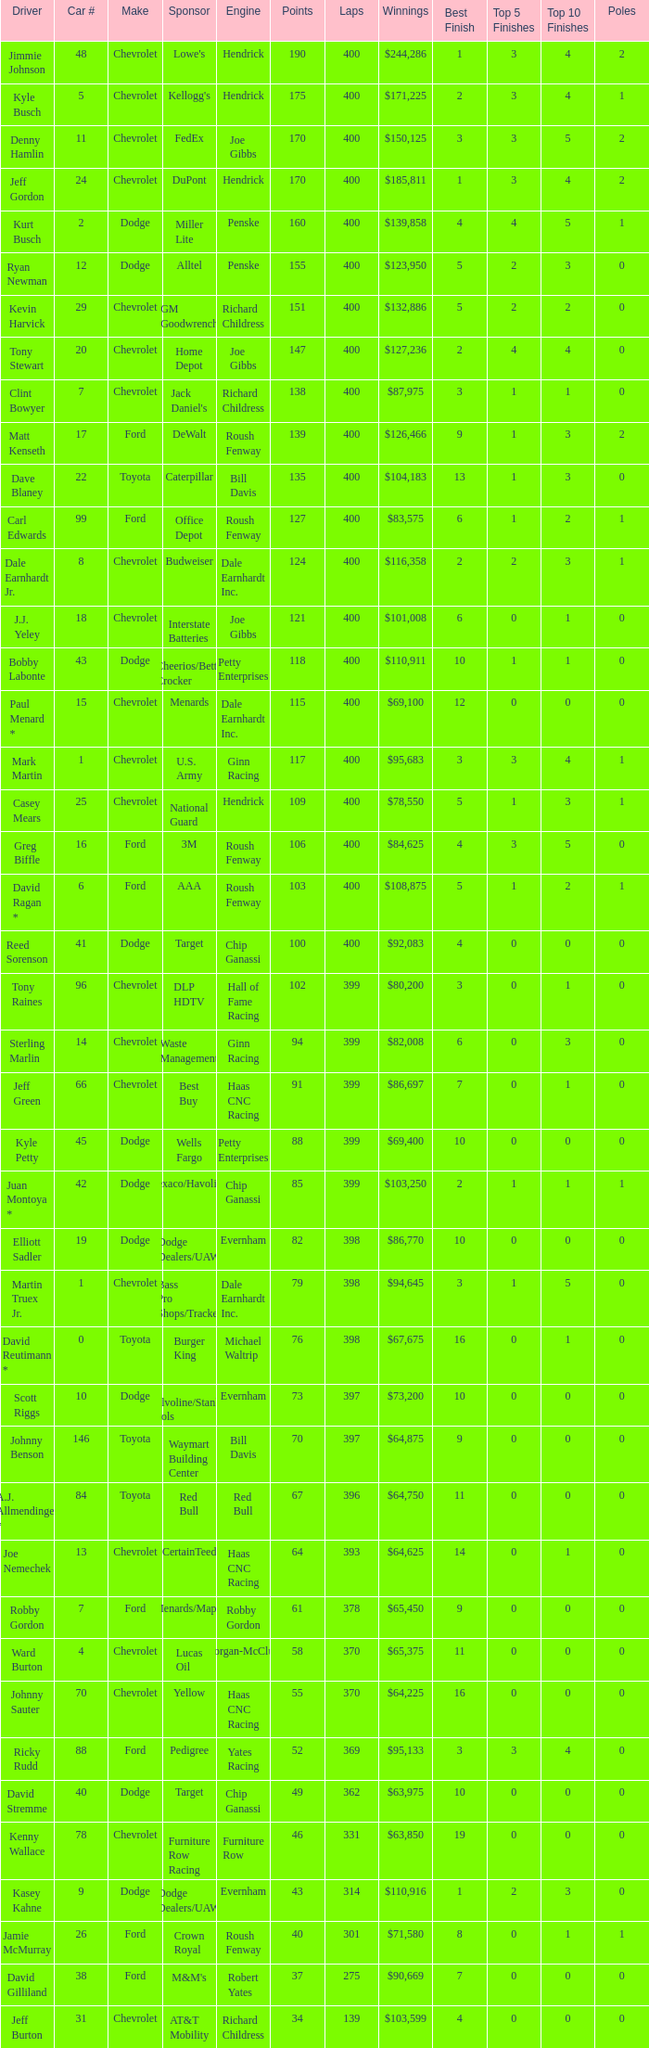Parse the full table. {'header': ['Driver', 'Car #', 'Make', 'Sponsor', 'Engine', 'Points', 'Laps', 'Winnings', 'Best Finish', 'Top 5 Finishes', 'Top 10 Finishes', 'Poles'], 'rows': [['Jimmie Johnson', '48', 'Chevrolet', "Lowe's", 'Hendrick', '190', '400', '$244,286', '1', '3', '4', '2'], ['Kyle Busch', '5', 'Chevrolet', "Kellogg's", 'Hendrick', '175', '400', '$171,225', '2', '3', '4', '1'], ['Denny Hamlin', '11', 'Chevrolet', 'FedEx', 'Joe Gibbs', '170', '400', '$150,125', '3', '3', '5', '2'], ['Jeff Gordon', '24', 'Chevrolet', 'DuPont', 'Hendrick', '170', '400', '$185,811', '1', '3', '4', '2'], ['Kurt Busch', '2', 'Dodge', 'Miller Lite', 'Penske', '160', '400', '$139,858', '4', '4', '5', '1'], ['Ryan Newman', '12', 'Dodge', 'Alltel', 'Penske', '155', '400', '$123,950', '5', '2', '3', '0'], ['Kevin Harvick', '29', 'Chevrolet', 'GM Goodwrench', 'Richard Childress', '151', '400', '$132,886', '5', '2', '2', '0'], ['Tony Stewart', '20', 'Chevrolet', 'Home Depot', 'Joe Gibbs', '147', '400', '$127,236', '2', '4', '4', '0'], ['Clint Bowyer', '7', 'Chevrolet', "Jack Daniel's", 'Richard Childress', '138', '400', '$87,975', '3', '1', '1', '0'], ['Matt Kenseth', '17', 'Ford', 'DeWalt', 'Roush Fenway', '139', '400', '$126,466', '9', '1', '3', '2'], ['Dave Blaney', '22', 'Toyota', 'Caterpillar', 'Bill Davis', '135', '400', '$104,183', '13', '1', '3', '0'], ['Carl Edwards', '99', 'Ford', 'Office Depot', 'Roush Fenway', '127', '400', '$83,575', '6', '1', '2', '1'], ['Dale Earnhardt Jr.', '8', 'Chevrolet', 'Budweiser', 'Dale Earnhardt Inc.', '124', '400', '$116,358', '2', '2', '3', '1'], ['J.J. Yeley', '18', 'Chevrolet', 'Interstate Batteries', 'Joe Gibbs', '121', '400', '$101,008', '6', '0', '1', '0'], ['Bobby Labonte', '43', 'Dodge', 'Cheerios/Betty Crocker', 'Petty Enterprises', '118', '400', '$110,911', '10', '1', '1', '0'], ['Paul Menard *', '15', 'Chevrolet', 'Menards', 'Dale Earnhardt Inc.', '115', '400', '$69,100', '12', '0', '0', '0'], ['Mark Martin', '1', 'Chevrolet', 'U.S. Army', 'Ginn Racing', '117', '400', '$95,683', '3', '3', '4', '1'], ['Casey Mears', '25', 'Chevrolet', 'National Guard', 'Hendrick', '109', '400', '$78,550', '5', '1', '3', '1'], ['Greg Biffle', '16', 'Ford', '3M', 'Roush Fenway', '106', '400', '$84,625', '4', '3', '5', '0'], ['David Ragan *', '6', 'Ford', 'AAA', 'Roush Fenway', '103', '400', '$108,875', '5', '1', '2', '1'], ['Reed Sorenson', '41', 'Dodge', 'Target', 'Chip Ganassi', '100', '400', '$92,083', '4', '0', '0', '0'], ['Tony Raines', '96', 'Chevrolet', 'DLP HDTV', 'Hall of Fame Racing', '102', '399', '$80,200', '3', '0', '1', '0'], ['Sterling Marlin', '14', 'Chevrolet', 'Waste Management', 'Ginn Racing', '94', '399', '$82,008', '6', '0', '3', '0'], ['Jeff Green', '66', 'Chevrolet', 'Best Buy', 'Haas CNC Racing', '91', '399', '$86,697', '7', '0', '1', '0'], ['Kyle Petty', '45', 'Dodge', 'Wells Fargo', 'Petty Enterprises', '88', '399', '$69,400', '10', '0', '0', '0'], ['Juan Montoya *', '42', 'Dodge', 'Texaco/Havoline', 'Chip Ganassi', '85', '399', '$103,250', '2', '1', '1', '1'], ['Elliott Sadler', '19', 'Dodge', 'Dodge Dealers/UAW', 'Evernham', '82', '398', '$86,770', '10', '0', '0', '0'], ['Martin Truex Jr.', '1', 'Chevrolet', 'Bass Pro Shops/Tracker', 'Dale Earnhardt Inc.', '79', '398', '$94,645', '3', '1', '5', '0'], ['David Reutimann *', '0', 'Toyota', 'Burger King', 'Michael Waltrip', '76', '398', '$67,675', '16', '0', '1', '0'], ['Scott Riggs', '10', 'Dodge', 'Valvoline/Stanley Tools', 'Evernham', '73', '397', '$73,200', '10', '0', '0', '0'], ['Johnny Benson', '146', 'Toyota', 'Waymart Building Center', 'Bill Davis', '70', '397', '$64,875', '9', '0', '0', '0'], ['A.J. Allmendinger *', '84', 'Toyota', 'Red Bull', 'Red Bull', '67', '396', '$64,750', '11', '0', '0', '0'], ['Joe Nemechek', '13', 'Chevrolet', 'CertainTeed', 'Haas CNC Racing', '64', '393', '$64,625', '14', '0', '1', '0'], ['Robby Gordon', '7', 'Ford', 'Menards/Mapei', 'Robby Gordon', '61', '378', '$65,450', '9', '0', '0', '0'], ['Ward Burton', '4', 'Chevrolet', 'Lucas Oil', 'Morgan-McClure', '58', '370', '$65,375', '11', '0', '0', '0'], ['Johnny Sauter', '70', 'Chevrolet', 'Yellow', 'Haas CNC Racing', '55', '370', '$64,225', '16', '0', '0', '0'], ['Ricky Rudd', '88', 'Ford', 'Pedigree', 'Yates Racing', '52', '369', '$95,133', '3', '3', '4', '0'], ['David Stremme', '40', 'Dodge', 'Target', 'Chip Ganassi', '49', '362', '$63,975', '10', '0', '0', '0'], ['Kenny Wallace', '78', 'Chevrolet', 'Furniture Row Racing', 'Furniture Row', '46', '331', '$63,850', '19', '0', '0', '0'], ['Kasey Kahne', '9', 'Dodge', 'Dodge Dealers/UAW', 'Evernham', '43', '314', '$110,916', '1', '2', '3', '0'], ['Jamie McMurray', '26', 'Ford', 'Crown Royal', 'Roush Fenway', '40', '301', '$71,580', '8', '0', '1', '1'], ['David Gilliland', '38', 'Ford', "M&M's", 'Robert Yates', '37', '275', '$90,669', '7', '0', '0', '0'], ['Jeff Burton', '31', 'Chevrolet', 'AT&amp;T Mobility', 'Richard Childress', '34', '139', '$103,599', '4', '0', '0', '0']]} What is the car number that has less than 369 laps for a Dodge with more than 49 points? None. 